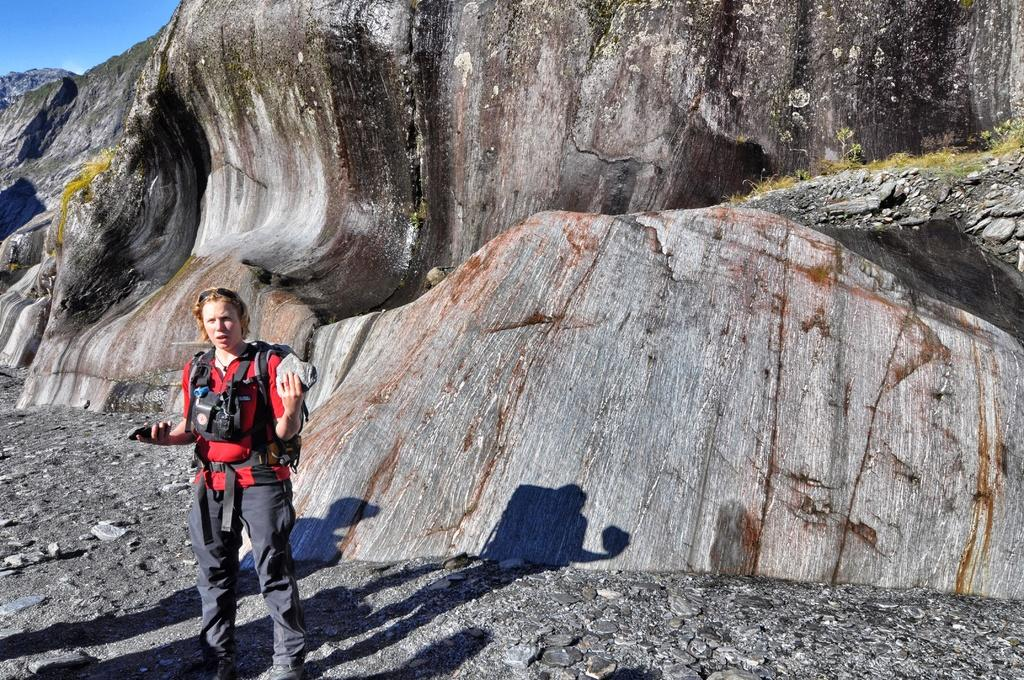Who is the main subject in the image? There is a girl in the image. Where is the girl located in the image? The girl is on the left side of the image. What can be seen in the background of the image? There are rocks in the background of the image. What type of sack is the girl carrying in the image? There is no sack visible in the image; the girl is not carrying anything. 